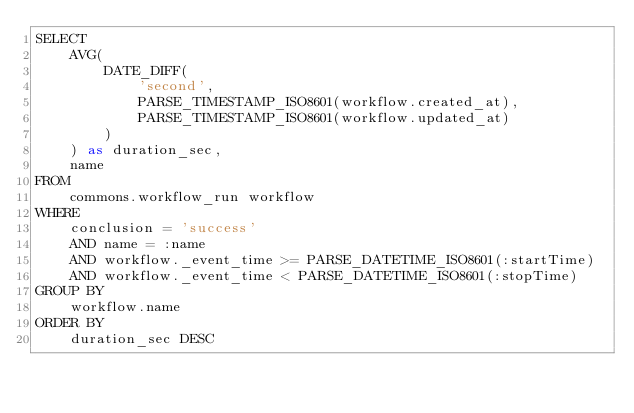Convert code to text. <code><loc_0><loc_0><loc_500><loc_500><_SQL_>SELECT
    AVG(
        DATE_DIFF(
            'second',
            PARSE_TIMESTAMP_ISO8601(workflow.created_at),
            PARSE_TIMESTAMP_ISO8601(workflow.updated_at)
        )
    ) as duration_sec,
    name
FROM
    commons.workflow_run workflow
WHERE
    conclusion = 'success'
    AND name = :name
    AND workflow._event_time >= PARSE_DATETIME_ISO8601(:startTime)
    AND workflow._event_time < PARSE_DATETIME_ISO8601(:stopTime)
GROUP BY
    workflow.name
ORDER BY
    duration_sec DESC
</code> 